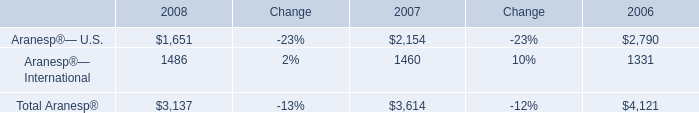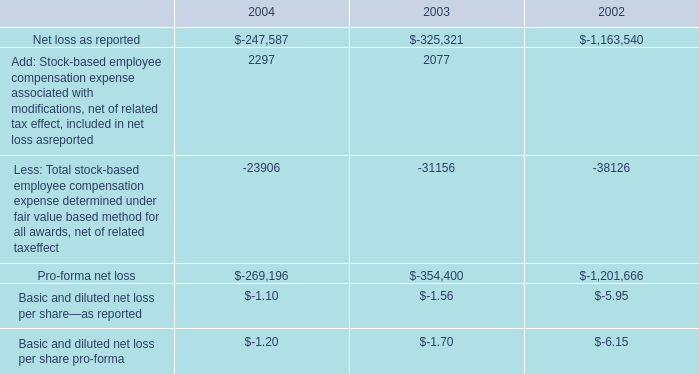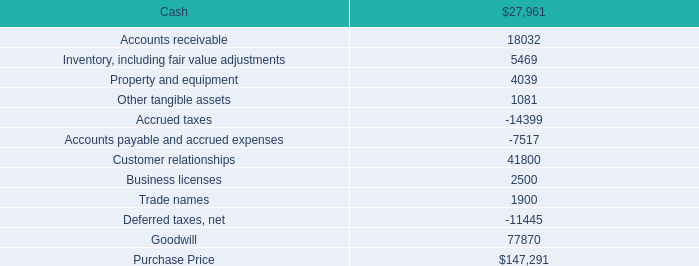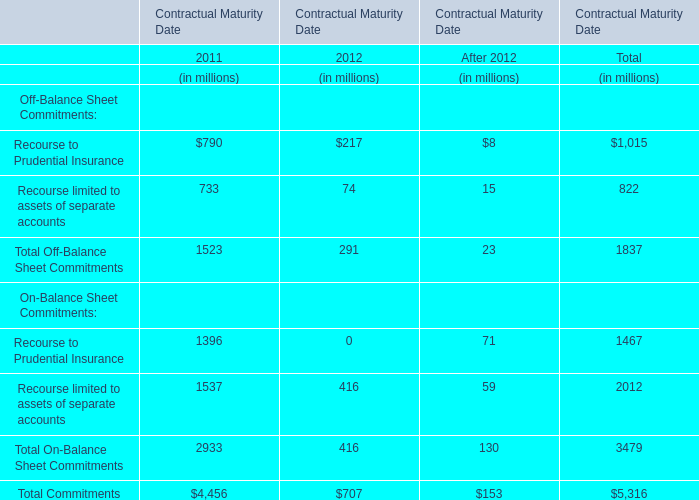What is the proportion of the Total On-Balance Sheet Commitments to the Total Commitments for Contractual Maturity Date 2012? 
Computations: (416 / 707)
Answer: 0.5884. 